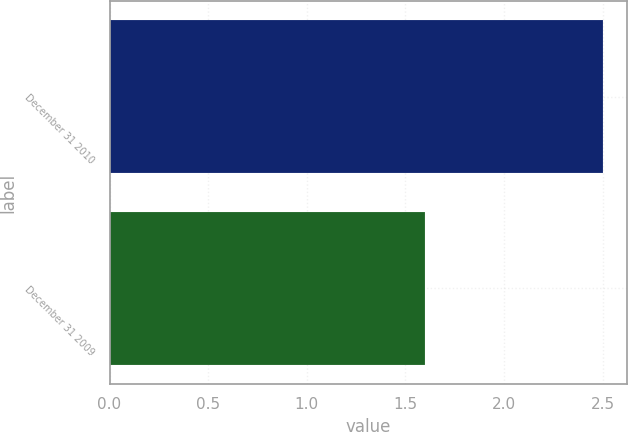Convert chart to OTSL. <chart><loc_0><loc_0><loc_500><loc_500><bar_chart><fcel>December 31 2010<fcel>December 31 2009<nl><fcel>2.5<fcel>1.6<nl></chart> 